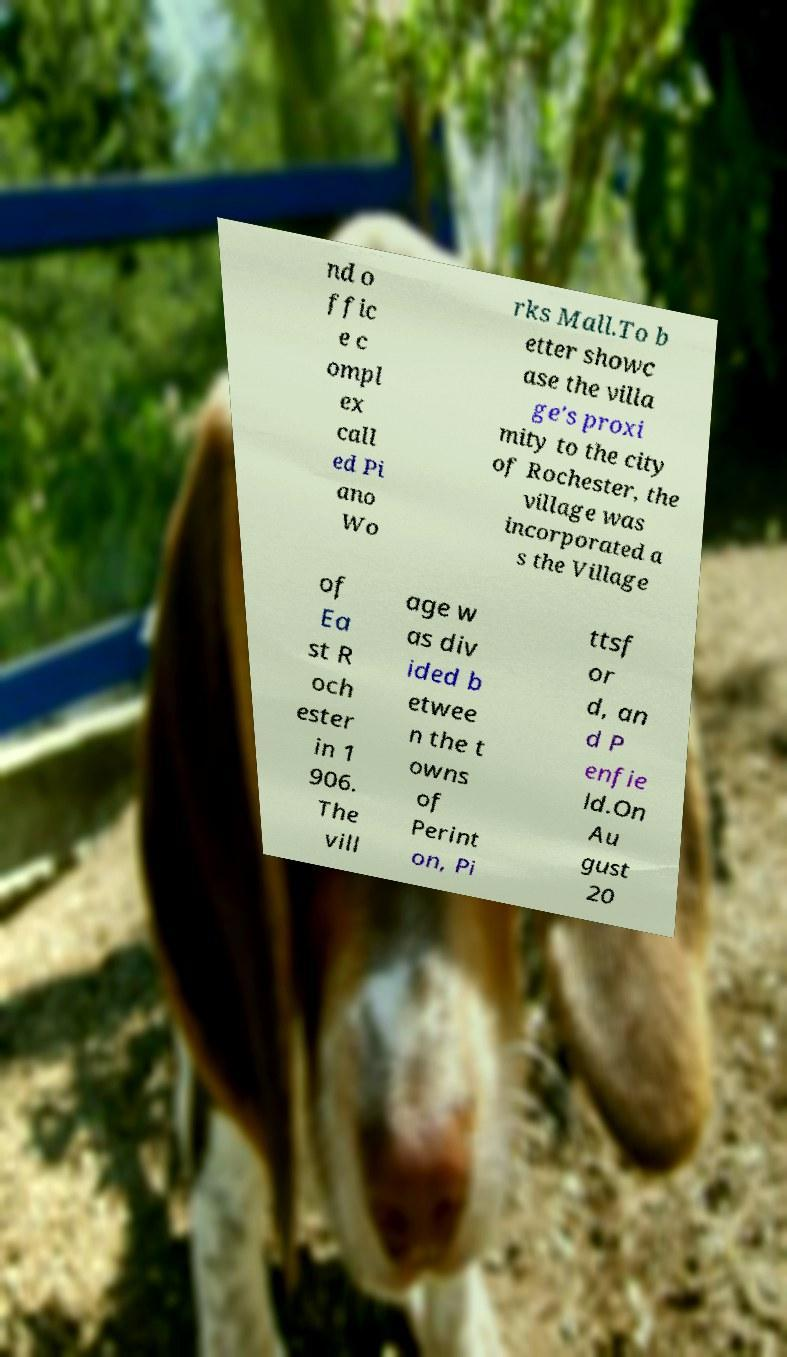Can you accurately transcribe the text from the provided image for me? nd o ffic e c ompl ex call ed Pi ano Wo rks Mall.To b etter showc ase the villa ge's proxi mity to the city of Rochester, the village was incorporated a s the Village of Ea st R och ester in 1 906. The vill age w as div ided b etwee n the t owns of Perint on, Pi ttsf or d, an d P enfie ld.On Au gust 20 